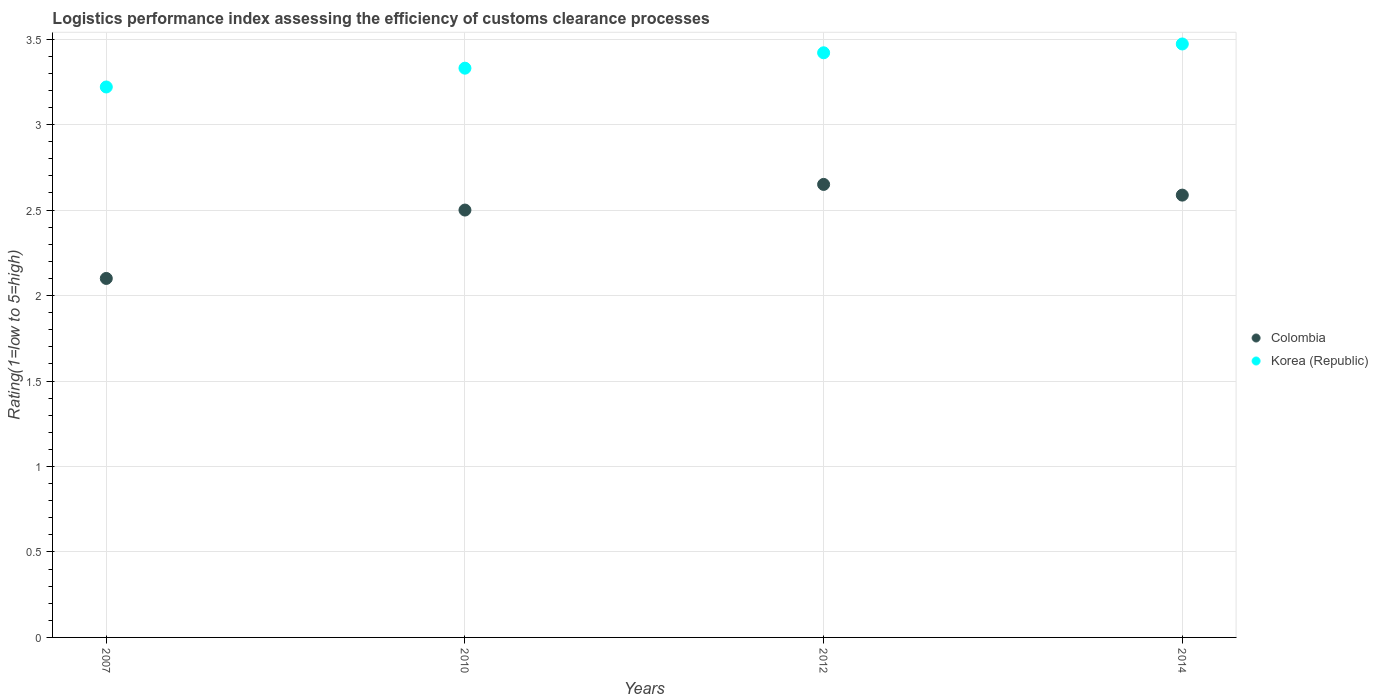What is the Logistic performance index in Colombia in 2012?
Your answer should be very brief. 2.65. Across all years, what is the maximum Logistic performance index in Colombia?
Offer a terse response. 2.65. Across all years, what is the minimum Logistic performance index in Korea (Republic)?
Make the answer very short. 3.22. What is the total Logistic performance index in Colombia in the graph?
Your answer should be compact. 9.84. What is the difference between the Logistic performance index in Colombia in 2007 and that in 2014?
Offer a terse response. -0.49. What is the difference between the Logistic performance index in Korea (Republic) in 2014 and the Logistic performance index in Colombia in 2010?
Offer a very short reply. 0.97. What is the average Logistic performance index in Korea (Republic) per year?
Provide a succinct answer. 3.36. In the year 2007, what is the difference between the Logistic performance index in Colombia and Logistic performance index in Korea (Republic)?
Make the answer very short. -1.12. In how many years, is the Logistic performance index in Colombia greater than 0.8?
Keep it short and to the point. 4. What is the ratio of the Logistic performance index in Colombia in 2010 to that in 2014?
Provide a short and direct response. 0.97. Is the difference between the Logistic performance index in Colombia in 2007 and 2012 greater than the difference between the Logistic performance index in Korea (Republic) in 2007 and 2012?
Offer a very short reply. No. What is the difference between the highest and the second highest Logistic performance index in Colombia?
Keep it short and to the point. 0.06. What is the difference between the highest and the lowest Logistic performance index in Colombia?
Your answer should be compact. 0.55. In how many years, is the Logistic performance index in Colombia greater than the average Logistic performance index in Colombia taken over all years?
Your answer should be compact. 3. Is the sum of the Logistic performance index in Korea (Republic) in 2007 and 2014 greater than the maximum Logistic performance index in Colombia across all years?
Give a very brief answer. Yes. Does the Logistic performance index in Korea (Republic) monotonically increase over the years?
Offer a terse response. Yes. Is the Logistic performance index in Korea (Republic) strictly greater than the Logistic performance index in Colombia over the years?
Your response must be concise. Yes. Is the Logistic performance index in Korea (Republic) strictly less than the Logistic performance index in Colombia over the years?
Offer a very short reply. No. How many dotlines are there?
Your answer should be very brief. 2. What is the difference between two consecutive major ticks on the Y-axis?
Your response must be concise. 0.5. Does the graph contain grids?
Give a very brief answer. Yes. What is the title of the graph?
Provide a short and direct response. Logistics performance index assessing the efficiency of customs clearance processes. Does "Samoa" appear as one of the legend labels in the graph?
Offer a very short reply. No. What is the label or title of the X-axis?
Offer a very short reply. Years. What is the label or title of the Y-axis?
Your response must be concise. Rating(1=low to 5=high). What is the Rating(1=low to 5=high) of Colombia in 2007?
Ensure brevity in your answer.  2.1. What is the Rating(1=low to 5=high) of Korea (Republic) in 2007?
Give a very brief answer. 3.22. What is the Rating(1=low to 5=high) in Korea (Republic) in 2010?
Your answer should be compact. 3.33. What is the Rating(1=low to 5=high) in Colombia in 2012?
Offer a very short reply. 2.65. What is the Rating(1=low to 5=high) of Korea (Republic) in 2012?
Your response must be concise. 3.42. What is the Rating(1=low to 5=high) in Colombia in 2014?
Give a very brief answer. 2.59. What is the Rating(1=low to 5=high) in Korea (Republic) in 2014?
Make the answer very short. 3.47. Across all years, what is the maximum Rating(1=low to 5=high) in Colombia?
Offer a very short reply. 2.65. Across all years, what is the maximum Rating(1=low to 5=high) of Korea (Republic)?
Keep it short and to the point. 3.47. Across all years, what is the minimum Rating(1=low to 5=high) of Korea (Republic)?
Keep it short and to the point. 3.22. What is the total Rating(1=low to 5=high) in Colombia in the graph?
Give a very brief answer. 9.84. What is the total Rating(1=low to 5=high) in Korea (Republic) in the graph?
Offer a terse response. 13.44. What is the difference between the Rating(1=low to 5=high) in Korea (Republic) in 2007 and that in 2010?
Your response must be concise. -0.11. What is the difference between the Rating(1=low to 5=high) of Colombia in 2007 and that in 2012?
Keep it short and to the point. -0.55. What is the difference between the Rating(1=low to 5=high) of Korea (Republic) in 2007 and that in 2012?
Provide a succinct answer. -0.2. What is the difference between the Rating(1=low to 5=high) of Colombia in 2007 and that in 2014?
Make the answer very short. -0.49. What is the difference between the Rating(1=low to 5=high) of Korea (Republic) in 2007 and that in 2014?
Provide a short and direct response. -0.25. What is the difference between the Rating(1=low to 5=high) in Korea (Republic) in 2010 and that in 2012?
Offer a terse response. -0.09. What is the difference between the Rating(1=low to 5=high) in Colombia in 2010 and that in 2014?
Make the answer very short. -0.09. What is the difference between the Rating(1=low to 5=high) of Korea (Republic) in 2010 and that in 2014?
Your response must be concise. -0.14. What is the difference between the Rating(1=low to 5=high) in Colombia in 2012 and that in 2014?
Give a very brief answer. 0.06. What is the difference between the Rating(1=low to 5=high) in Korea (Republic) in 2012 and that in 2014?
Provide a short and direct response. -0.05. What is the difference between the Rating(1=low to 5=high) of Colombia in 2007 and the Rating(1=low to 5=high) of Korea (Republic) in 2010?
Provide a succinct answer. -1.23. What is the difference between the Rating(1=low to 5=high) in Colombia in 2007 and the Rating(1=low to 5=high) in Korea (Republic) in 2012?
Your response must be concise. -1.32. What is the difference between the Rating(1=low to 5=high) of Colombia in 2007 and the Rating(1=low to 5=high) of Korea (Republic) in 2014?
Make the answer very short. -1.37. What is the difference between the Rating(1=low to 5=high) of Colombia in 2010 and the Rating(1=low to 5=high) of Korea (Republic) in 2012?
Give a very brief answer. -0.92. What is the difference between the Rating(1=low to 5=high) of Colombia in 2010 and the Rating(1=low to 5=high) of Korea (Republic) in 2014?
Your answer should be very brief. -0.97. What is the difference between the Rating(1=low to 5=high) in Colombia in 2012 and the Rating(1=low to 5=high) in Korea (Republic) in 2014?
Make the answer very short. -0.82. What is the average Rating(1=low to 5=high) in Colombia per year?
Provide a succinct answer. 2.46. What is the average Rating(1=low to 5=high) in Korea (Republic) per year?
Give a very brief answer. 3.36. In the year 2007, what is the difference between the Rating(1=low to 5=high) in Colombia and Rating(1=low to 5=high) in Korea (Republic)?
Make the answer very short. -1.12. In the year 2010, what is the difference between the Rating(1=low to 5=high) of Colombia and Rating(1=low to 5=high) of Korea (Republic)?
Give a very brief answer. -0.83. In the year 2012, what is the difference between the Rating(1=low to 5=high) in Colombia and Rating(1=low to 5=high) in Korea (Republic)?
Make the answer very short. -0.77. In the year 2014, what is the difference between the Rating(1=low to 5=high) of Colombia and Rating(1=low to 5=high) of Korea (Republic)?
Provide a succinct answer. -0.88. What is the ratio of the Rating(1=low to 5=high) in Colombia in 2007 to that in 2010?
Make the answer very short. 0.84. What is the ratio of the Rating(1=low to 5=high) in Colombia in 2007 to that in 2012?
Provide a short and direct response. 0.79. What is the ratio of the Rating(1=low to 5=high) of Korea (Republic) in 2007 to that in 2012?
Make the answer very short. 0.94. What is the ratio of the Rating(1=low to 5=high) in Colombia in 2007 to that in 2014?
Provide a short and direct response. 0.81. What is the ratio of the Rating(1=low to 5=high) in Korea (Republic) in 2007 to that in 2014?
Provide a short and direct response. 0.93. What is the ratio of the Rating(1=low to 5=high) of Colombia in 2010 to that in 2012?
Offer a very short reply. 0.94. What is the ratio of the Rating(1=low to 5=high) of Korea (Republic) in 2010 to that in 2012?
Make the answer very short. 0.97. What is the ratio of the Rating(1=low to 5=high) in Colombia in 2010 to that in 2014?
Provide a short and direct response. 0.97. What is the ratio of the Rating(1=low to 5=high) in Korea (Republic) in 2010 to that in 2014?
Give a very brief answer. 0.96. What is the ratio of the Rating(1=low to 5=high) in Colombia in 2012 to that in 2014?
Offer a very short reply. 1.02. What is the ratio of the Rating(1=low to 5=high) of Korea (Republic) in 2012 to that in 2014?
Your answer should be very brief. 0.99. What is the difference between the highest and the second highest Rating(1=low to 5=high) of Colombia?
Offer a terse response. 0.06. What is the difference between the highest and the second highest Rating(1=low to 5=high) in Korea (Republic)?
Keep it short and to the point. 0.05. What is the difference between the highest and the lowest Rating(1=low to 5=high) in Colombia?
Ensure brevity in your answer.  0.55. What is the difference between the highest and the lowest Rating(1=low to 5=high) in Korea (Republic)?
Your answer should be very brief. 0.25. 